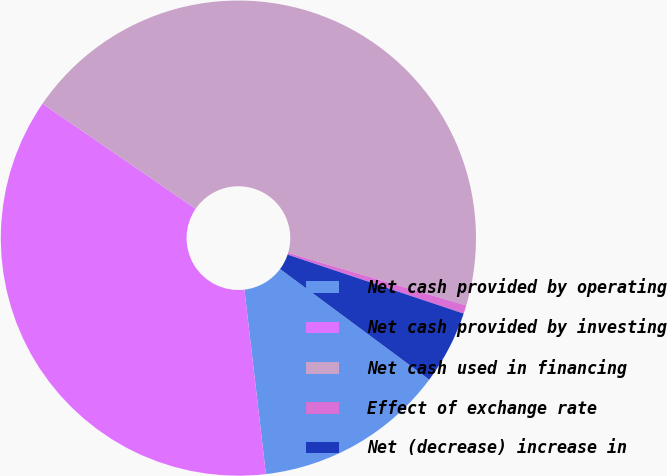Convert chart. <chart><loc_0><loc_0><loc_500><loc_500><pie_chart><fcel>Net cash provided by operating<fcel>Net cash provided by investing<fcel>Net cash used in financing<fcel>Effect of exchange rate<fcel>Net (decrease) increase in<nl><fcel>13.0%<fcel>36.42%<fcel>45.0%<fcel>0.57%<fcel>5.01%<nl></chart> 